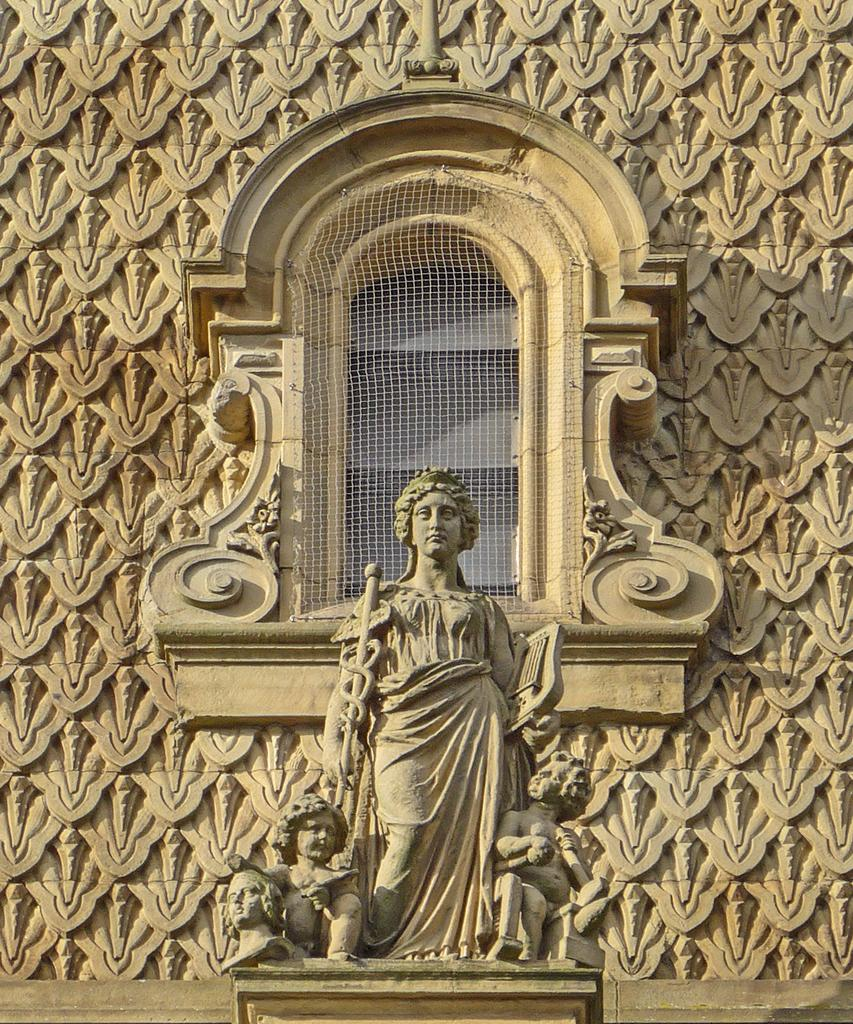What is located in the center of the image? There is a wall, a window, and statues in the center of the image. What can be seen through the window in the image? Unfortunately, the view through the window cannot be determined from the image. What is on the wall in the image? There is artwork on the wall in the image. What type of wood is used for the floor in the image? There is no mention of a floor in the provided facts, and therefore no information about the type of wood used. 